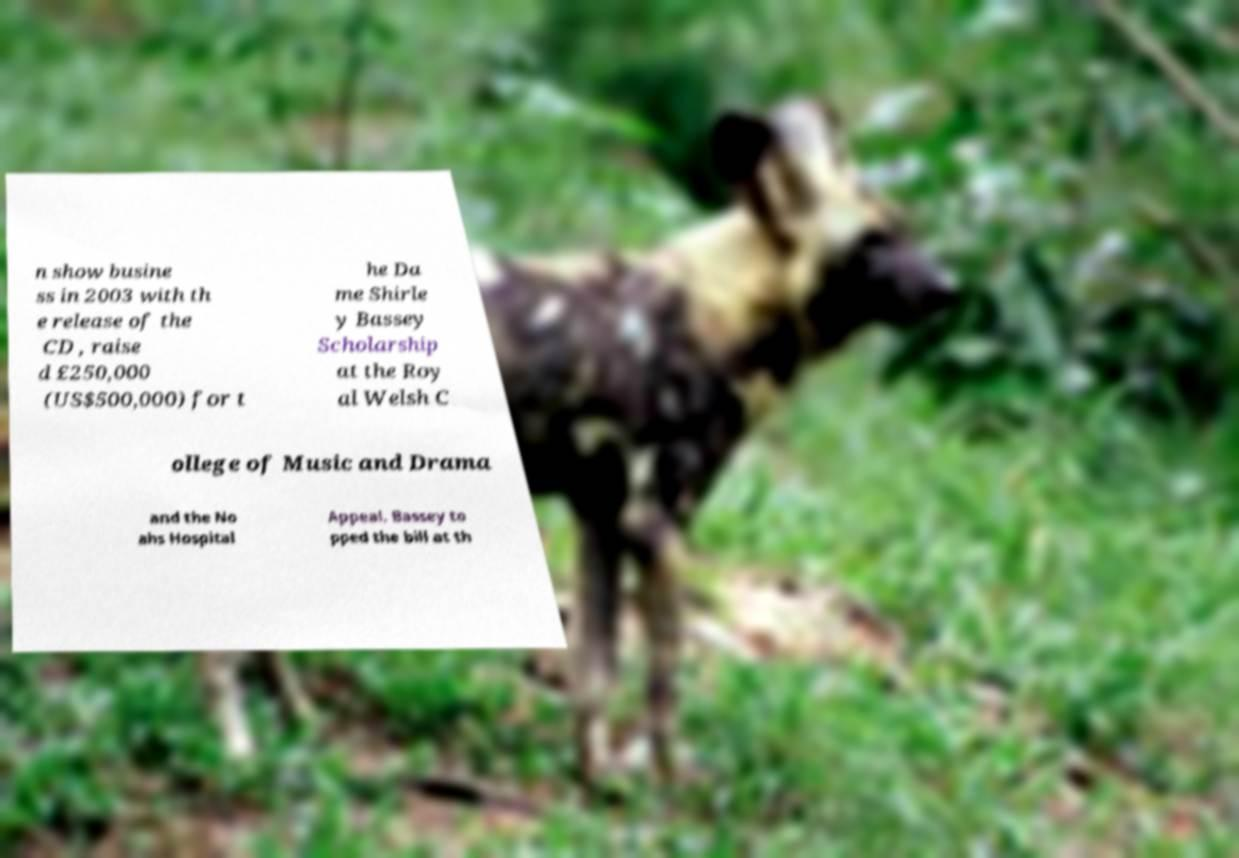I need the written content from this picture converted into text. Can you do that? n show busine ss in 2003 with th e release of the CD , raise d £250,000 (US$500,000) for t he Da me Shirle y Bassey Scholarship at the Roy al Welsh C ollege of Music and Drama and the No ahs Hospital Appeal. Bassey to pped the bill at th 